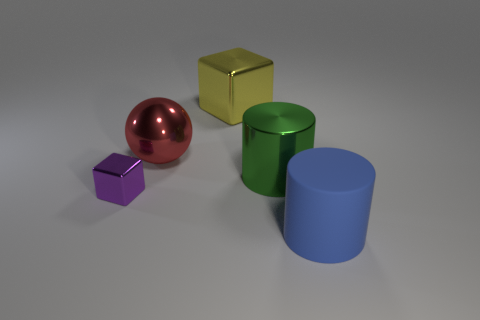Add 2 small yellow matte spheres. How many objects exist? 7 Subtract all cylinders. How many objects are left? 3 Add 5 large matte cylinders. How many large matte cylinders are left? 6 Add 3 red spheres. How many red spheres exist? 4 Subtract 1 purple blocks. How many objects are left? 4 Subtract all tiny blue objects. Subtract all metal balls. How many objects are left? 4 